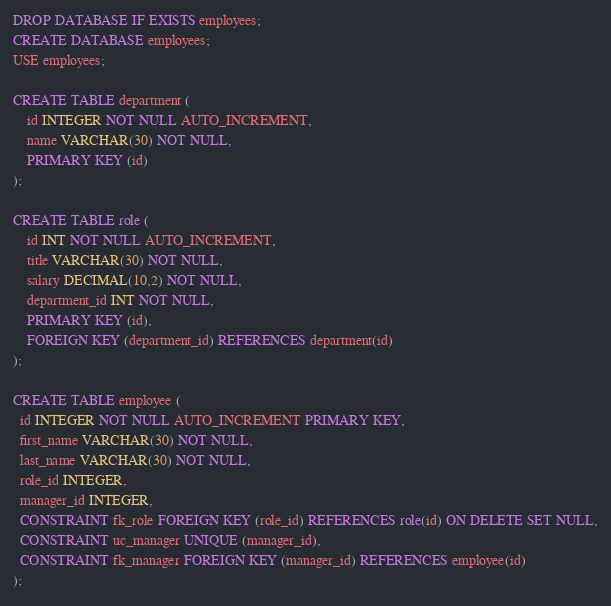Convert code to text. <code><loc_0><loc_0><loc_500><loc_500><_SQL_>DROP DATABASE IF EXISTS employees;
CREATE DATABASE employees;
USE employees;

CREATE TABLE department (
    id INTEGER NOT NULL AUTO_INCREMENT,
    name VARCHAR(30) NOT NULL,
    PRIMARY KEY (id)
);

CREATE TABLE role (
    id INT NOT NULL AUTO_INCREMENT,
    title VARCHAR(30) NOT NULL,
    salary DECIMAL(10,2) NOT NULL,
    department_id INT NOT NULL,
    PRIMARY KEY (id),
    FOREIGN KEY (department_id) REFERENCES department(id)   
);

CREATE TABLE employee (
  id INTEGER NOT NULL AUTO_INCREMENT PRIMARY KEY,
  first_name VARCHAR(30) NOT NULL,
  last_name VARCHAR(30) NOT NULL,
  role_id INTEGER,
  manager_id INTEGER,
  CONSTRAINT fk_role FOREIGN KEY (role_id) REFERENCES role(id) ON DELETE SET NULL,
  CONSTRAINT uc_manager UNIQUE (manager_id),
  CONSTRAINT fk_manager FOREIGN KEY (manager_id) REFERENCES employee(id)
);</code> 